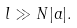Convert formula to latex. <formula><loc_0><loc_0><loc_500><loc_500>l \gg N | a | .</formula> 